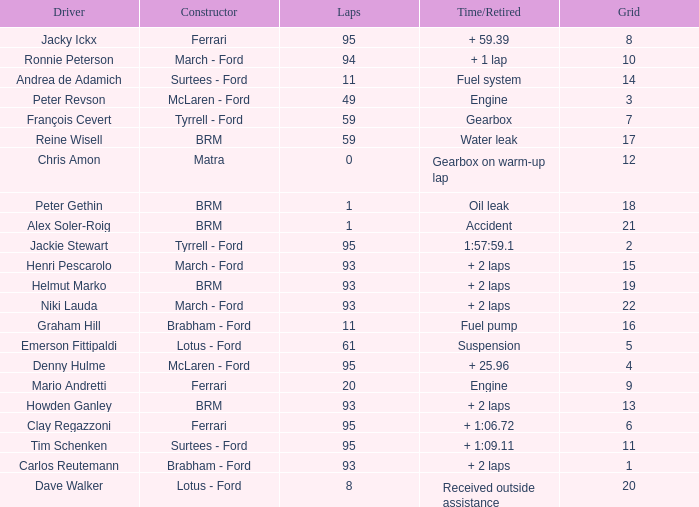What is the total number of grids for peter gethin? 18.0. 